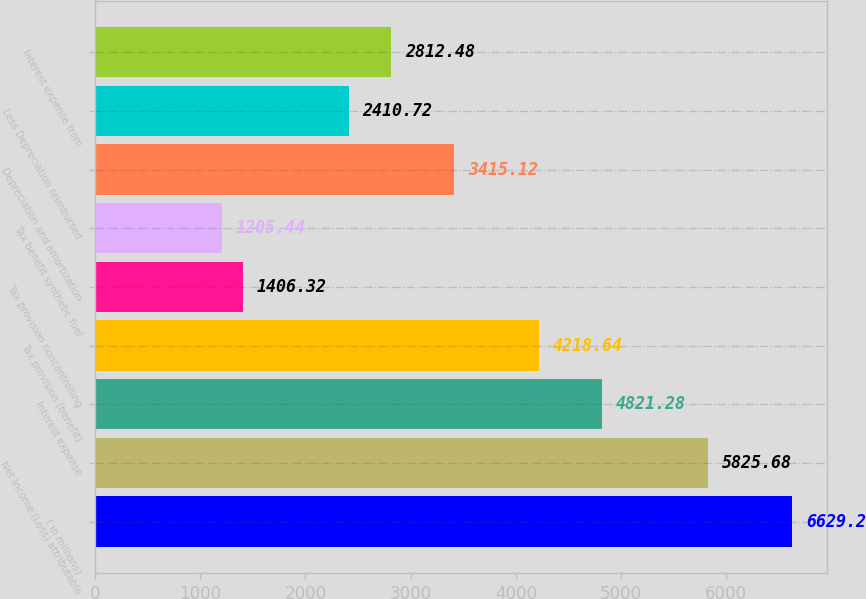Convert chart. <chart><loc_0><loc_0><loc_500><loc_500><bar_chart><fcel>( in millions)<fcel>Net Income (Loss) attributable<fcel>Interest expense<fcel>Tax provision (benefit)<fcel>Tax provision noncontrolling<fcel>Tax benefit synthetic fuel<fcel>Depreciation and amortization<fcel>Less Depreciation reimbursed<fcel>Interest expense from<nl><fcel>6629.2<fcel>5825.68<fcel>4821.28<fcel>4218.64<fcel>1406.32<fcel>1205.44<fcel>3415.12<fcel>2410.72<fcel>2812.48<nl></chart> 